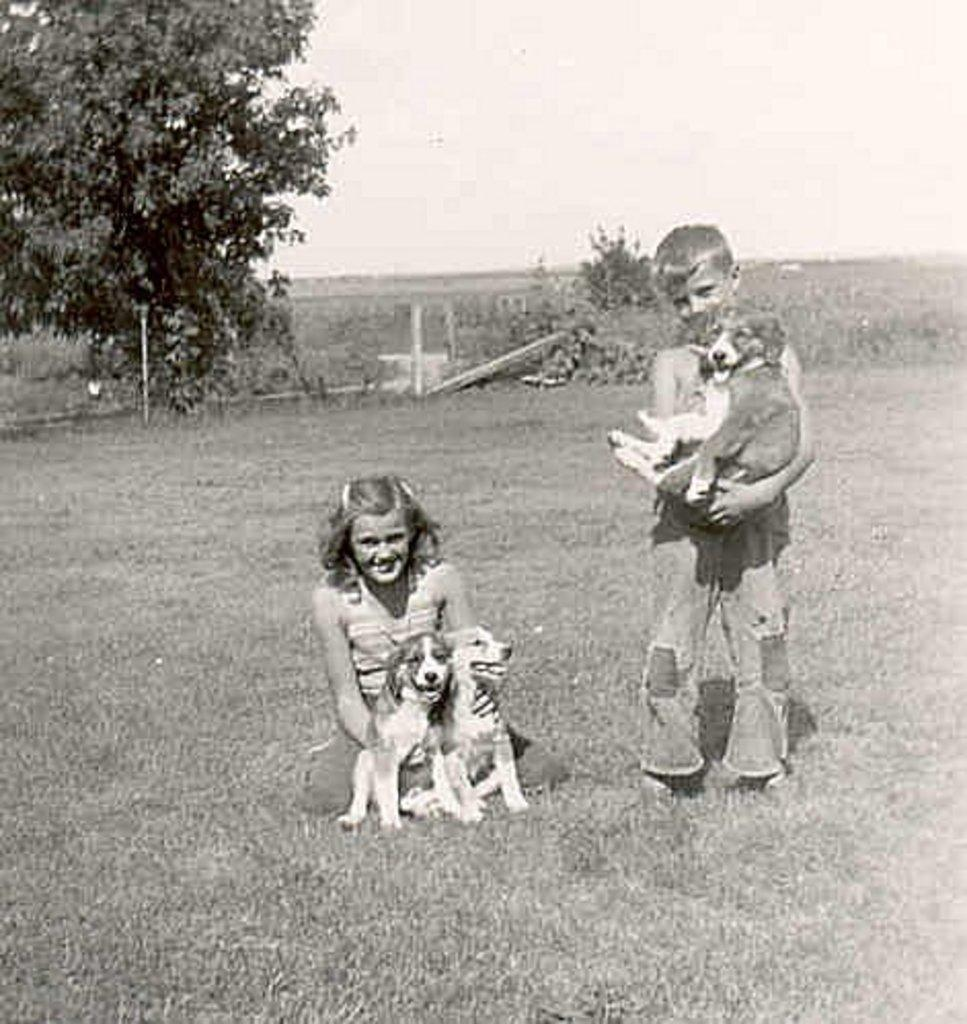How many people are present in the image? There are two people in the image. What are the people holding in the image? The people are holding dogs in the image. What can be seen in the background of the image? There are trees visible in the background of the image. What type of plastic object is being used by the people to walk their dogs in the image? There is no plastic object being used by the people to walk their dogs in the image; they are simply holding the dogs. 